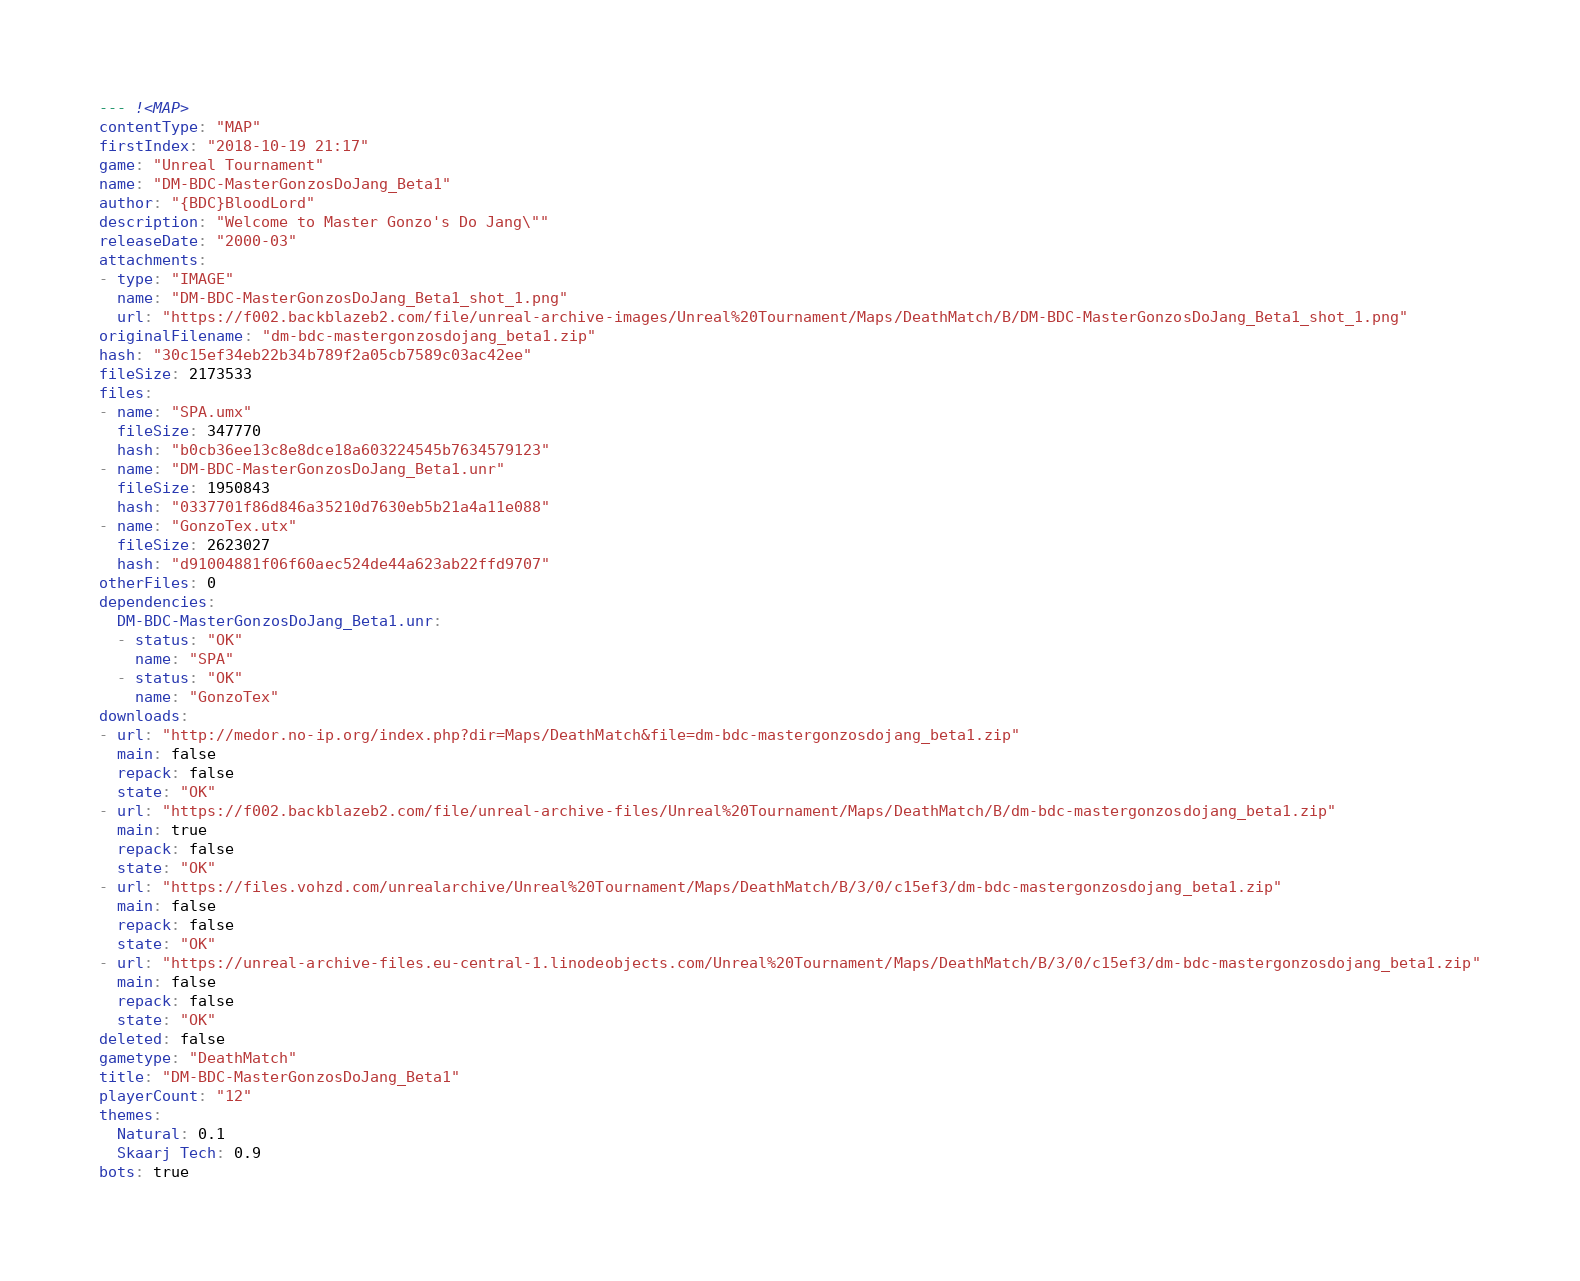<code> <loc_0><loc_0><loc_500><loc_500><_YAML_>--- !<MAP>
contentType: "MAP"
firstIndex: "2018-10-19 21:17"
game: "Unreal Tournament"
name: "DM-BDC-MasterGonzosDoJang_Beta1"
author: "{BDC}BloodLord"
description: "Welcome to Master Gonzo's Do Jang\""
releaseDate: "2000-03"
attachments:
- type: "IMAGE"
  name: "DM-BDC-MasterGonzosDoJang_Beta1_shot_1.png"
  url: "https://f002.backblazeb2.com/file/unreal-archive-images/Unreal%20Tournament/Maps/DeathMatch/B/DM-BDC-MasterGonzosDoJang_Beta1_shot_1.png"
originalFilename: "dm-bdc-mastergonzosdojang_beta1.zip"
hash: "30c15ef34eb22b34b789f2a05cb7589c03ac42ee"
fileSize: 2173533
files:
- name: "SPA.umx"
  fileSize: 347770
  hash: "b0cb36ee13c8e8dce18a603224545b7634579123"
- name: "DM-BDC-MasterGonzosDoJang_Beta1.unr"
  fileSize: 1950843
  hash: "0337701f86d846a35210d7630eb5b21a4a11e088"
- name: "GonzoTex.utx"
  fileSize: 2623027
  hash: "d91004881f06f60aec524de44a623ab22ffd9707"
otherFiles: 0
dependencies:
  DM-BDC-MasterGonzosDoJang_Beta1.unr:
  - status: "OK"
    name: "SPA"
  - status: "OK"
    name: "GonzoTex"
downloads:
- url: "http://medor.no-ip.org/index.php?dir=Maps/DeathMatch&file=dm-bdc-mastergonzosdojang_beta1.zip"
  main: false
  repack: false
  state: "OK"
- url: "https://f002.backblazeb2.com/file/unreal-archive-files/Unreal%20Tournament/Maps/DeathMatch/B/dm-bdc-mastergonzosdojang_beta1.zip"
  main: true
  repack: false
  state: "OK"
- url: "https://files.vohzd.com/unrealarchive/Unreal%20Tournament/Maps/DeathMatch/B/3/0/c15ef3/dm-bdc-mastergonzosdojang_beta1.zip"
  main: false
  repack: false
  state: "OK"
- url: "https://unreal-archive-files.eu-central-1.linodeobjects.com/Unreal%20Tournament/Maps/DeathMatch/B/3/0/c15ef3/dm-bdc-mastergonzosdojang_beta1.zip"
  main: false
  repack: false
  state: "OK"
deleted: false
gametype: "DeathMatch"
title: "DM-BDC-MasterGonzosDoJang_Beta1"
playerCount: "12"
themes:
  Natural: 0.1
  Skaarj Tech: 0.9
bots: true
</code> 